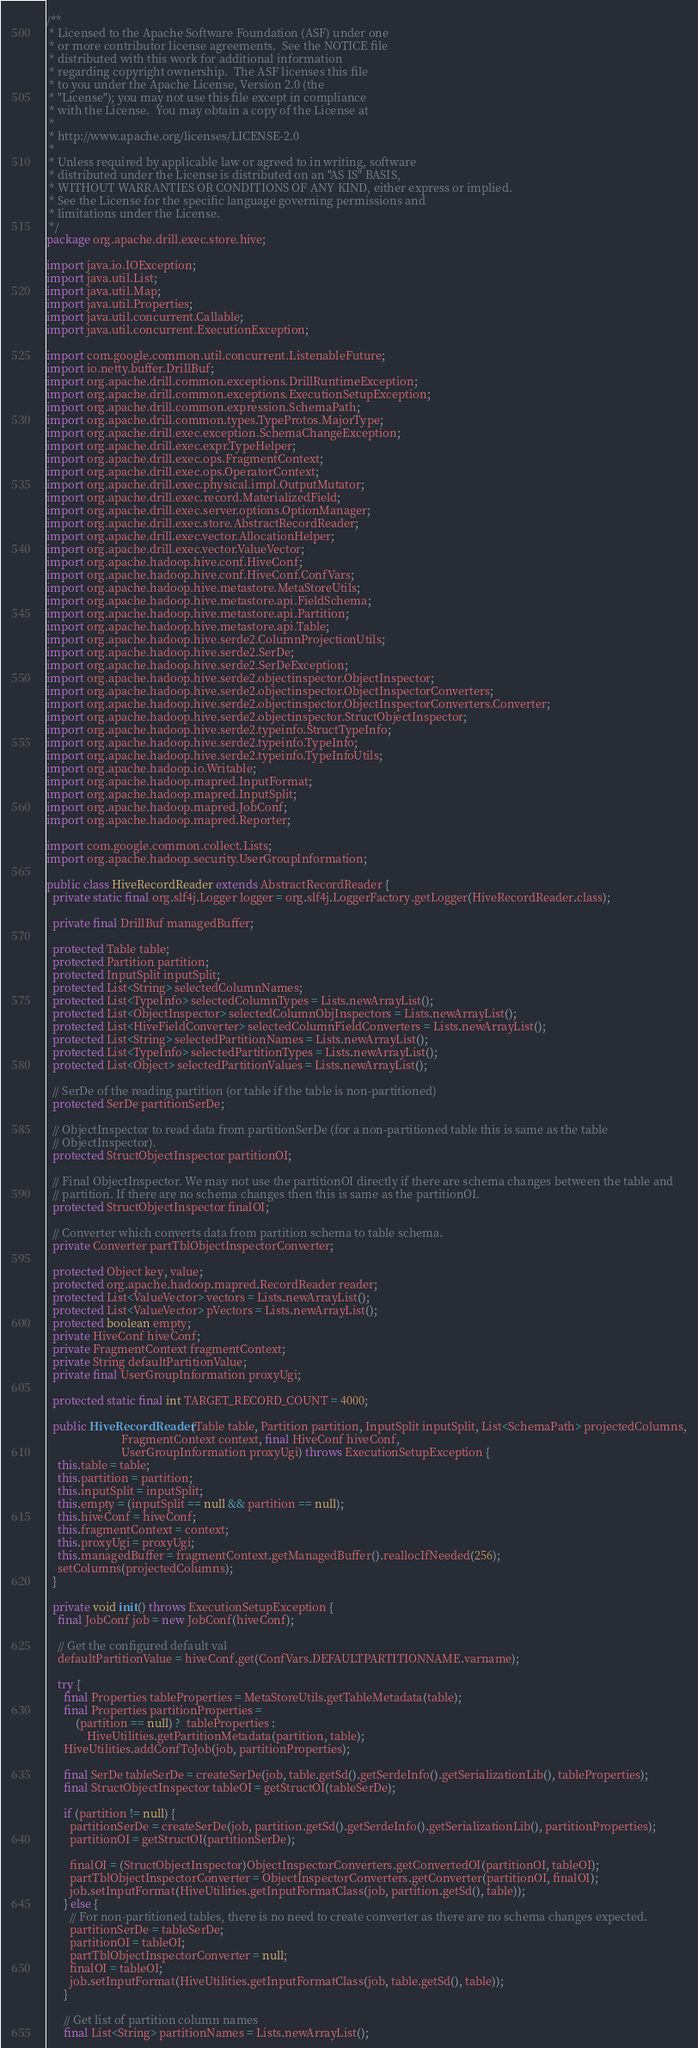Convert code to text. <code><loc_0><loc_0><loc_500><loc_500><_Java_>/**
 * Licensed to the Apache Software Foundation (ASF) under one
 * or more contributor license agreements.  See the NOTICE file
 * distributed with this work for additional information
 * regarding copyright ownership.  The ASF licenses this file
 * to you under the Apache License, Version 2.0 (the
 * "License"); you may not use this file except in compliance
 * with the License.  You may obtain a copy of the License at
 *
 * http://www.apache.org/licenses/LICENSE-2.0
 *
 * Unless required by applicable law or agreed to in writing, software
 * distributed under the License is distributed on an "AS IS" BASIS,
 * WITHOUT WARRANTIES OR CONDITIONS OF ANY KIND, either express or implied.
 * See the License for the specific language governing permissions and
 * limitations under the License.
 */
package org.apache.drill.exec.store.hive;

import java.io.IOException;
import java.util.List;
import java.util.Map;
import java.util.Properties;
import java.util.concurrent.Callable;
import java.util.concurrent.ExecutionException;

import com.google.common.util.concurrent.ListenableFuture;
import io.netty.buffer.DrillBuf;
import org.apache.drill.common.exceptions.DrillRuntimeException;
import org.apache.drill.common.exceptions.ExecutionSetupException;
import org.apache.drill.common.expression.SchemaPath;
import org.apache.drill.common.types.TypeProtos.MajorType;
import org.apache.drill.exec.exception.SchemaChangeException;
import org.apache.drill.exec.expr.TypeHelper;
import org.apache.drill.exec.ops.FragmentContext;
import org.apache.drill.exec.ops.OperatorContext;
import org.apache.drill.exec.physical.impl.OutputMutator;
import org.apache.drill.exec.record.MaterializedField;
import org.apache.drill.exec.server.options.OptionManager;
import org.apache.drill.exec.store.AbstractRecordReader;
import org.apache.drill.exec.vector.AllocationHelper;
import org.apache.drill.exec.vector.ValueVector;
import org.apache.hadoop.hive.conf.HiveConf;
import org.apache.hadoop.hive.conf.HiveConf.ConfVars;
import org.apache.hadoop.hive.metastore.MetaStoreUtils;
import org.apache.hadoop.hive.metastore.api.FieldSchema;
import org.apache.hadoop.hive.metastore.api.Partition;
import org.apache.hadoop.hive.metastore.api.Table;
import org.apache.hadoop.hive.serde2.ColumnProjectionUtils;
import org.apache.hadoop.hive.serde2.SerDe;
import org.apache.hadoop.hive.serde2.SerDeException;
import org.apache.hadoop.hive.serde2.objectinspector.ObjectInspector;
import org.apache.hadoop.hive.serde2.objectinspector.ObjectInspectorConverters;
import org.apache.hadoop.hive.serde2.objectinspector.ObjectInspectorConverters.Converter;
import org.apache.hadoop.hive.serde2.objectinspector.StructObjectInspector;
import org.apache.hadoop.hive.serde2.typeinfo.StructTypeInfo;
import org.apache.hadoop.hive.serde2.typeinfo.TypeInfo;
import org.apache.hadoop.hive.serde2.typeinfo.TypeInfoUtils;
import org.apache.hadoop.io.Writable;
import org.apache.hadoop.mapred.InputFormat;
import org.apache.hadoop.mapred.InputSplit;
import org.apache.hadoop.mapred.JobConf;
import org.apache.hadoop.mapred.Reporter;

import com.google.common.collect.Lists;
import org.apache.hadoop.security.UserGroupInformation;

public class HiveRecordReader extends AbstractRecordReader {
  private static final org.slf4j.Logger logger = org.slf4j.LoggerFactory.getLogger(HiveRecordReader.class);

  private final DrillBuf managedBuffer;

  protected Table table;
  protected Partition partition;
  protected InputSplit inputSplit;
  protected List<String> selectedColumnNames;
  protected List<TypeInfo> selectedColumnTypes = Lists.newArrayList();
  protected List<ObjectInspector> selectedColumnObjInspectors = Lists.newArrayList();
  protected List<HiveFieldConverter> selectedColumnFieldConverters = Lists.newArrayList();
  protected List<String> selectedPartitionNames = Lists.newArrayList();
  protected List<TypeInfo> selectedPartitionTypes = Lists.newArrayList();
  protected List<Object> selectedPartitionValues = Lists.newArrayList();

  // SerDe of the reading partition (or table if the table is non-partitioned)
  protected SerDe partitionSerDe;

  // ObjectInspector to read data from partitionSerDe (for a non-partitioned table this is same as the table
  // ObjectInspector).
  protected StructObjectInspector partitionOI;

  // Final ObjectInspector. We may not use the partitionOI directly if there are schema changes between the table and
  // partition. If there are no schema changes then this is same as the partitionOI.
  protected StructObjectInspector finalOI;

  // Converter which converts data from partition schema to table schema.
  private Converter partTblObjectInspectorConverter;

  protected Object key, value;
  protected org.apache.hadoop.mapred.RecordReader reader;
  protected List<ValueVector> vectors = Lists.newArrayList();
  protected List<ValueVector> pVectors = Lists.newArrayList();
  protected boolean empty;
  private HiveConf hiveConf;
  private FragmentContext fragmentContext;
  private String defaultPartitionValue;
  private final UserGroupInformation proxyUgi;

  protected static final int TARGET_RECORD_COUNT = 4000;

  public HiveRecordReader(Table table, Partition partition, InputSplit inputSplit, List<SchemaPath> projectedColumns,
                          FragmentContext context, final HiveConf hiveConf,
                          UserGroupInformation proxyUgi) throws ExecutionSetupException {
    this.table = table;
    this.partition = partition;
    this.inputSplit = inputSplit;
    this.empty = (inputSplit == null && partition == null);
    this.hiveConf = hiveConf;
    this.fragmentContext = context;
    this.proxyUgi = proxyUgi;
    this.managedBuffer = fragmentContext.getManagedBuffer().reallocIfNeeded(256);
    setColumns(projectedColumns);
  }

  private void init() throws ExecutionSetupException {
    final JobConf job = new JobConf(hiveConf);

    // Get the configured default val
    defaultPartitionValue = hiveConf.get(ConfVars.DEFAULTPARTITIONNAME.varname);

    try {
      final Properties tableProperties = MetaStoreUtils.getTableMetadata(table);
      final Properties partitionProperties =
          (partition == null) ?  tableProperties :
              HiveUtilities.getPartitionMetadata(partition, table);
      HiveUtilities.addConfToJob(job, partitionProperties);

      final SerDe tableSerDe = createSerDe(job, table.getSd().getSerdeInfo().getSerializationLib(), tableProperties);
      final StructObjectInspector tableOI = getStructOI(tableSerDe);

      if (partition != null) {
        partitionSerDe = createSerDe(job, partition.getSd().getSerdeInfo().getSerializationLib(), partitionProperties);
        partitionOI = getStructOI(partitionSerDe);

        finalOI = (StructObjectInspector)ObjectInspectorConverters.getConvertedOI(partitionOI, tableOI);
        partTblObjectInspectorConverter = ObjectInspectorConverters.getConverter(partitionOI, finalOI);
        job.setInputFormat(HiveUtilities.getInputFormatClass(job, partition.getSd(), table));
      } else {
        // For non-partitioned tables, there is no need to create converter as there are no schema changes expected.
        partitionSerDe = tableSerDe;
        partitionOI = tableOI;
        partTblObjectInspectorConverter = null;
        finalOI = tableOI;
        job.setInputFormat(HiveUtilities.getInputFormatClass(job, table.getSd(), table));
      }

      // Get list of partition column names
      final List<String> partitionNames = Lists.newArrayList();</code> 